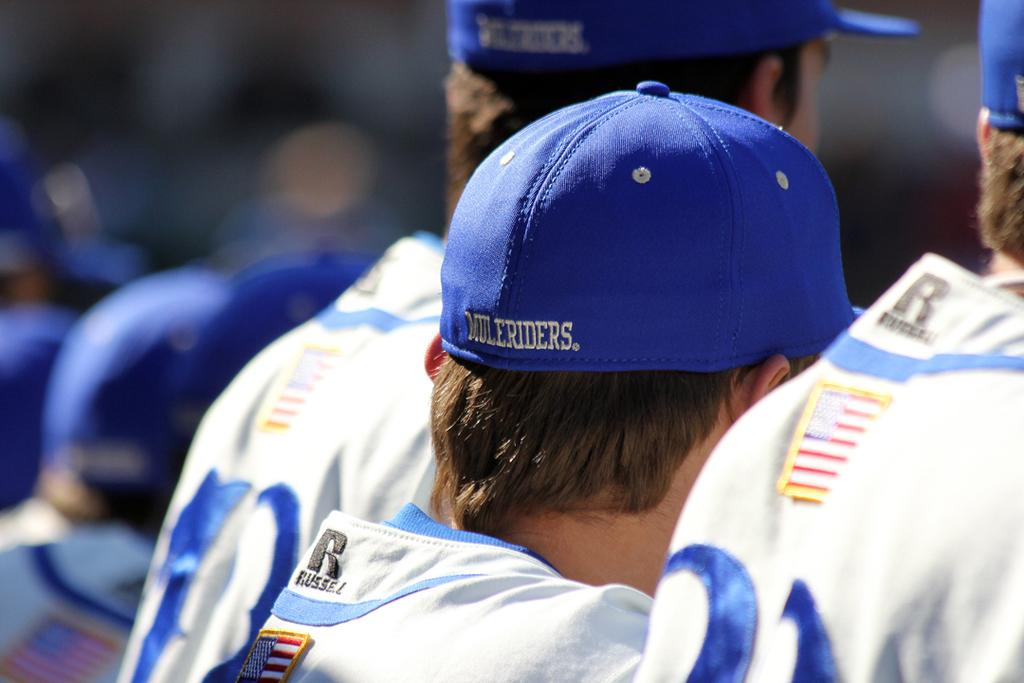<image>
Give a short and clear explanation of the subsequent image. A man in a Muleriders hat stands in line with other players. 